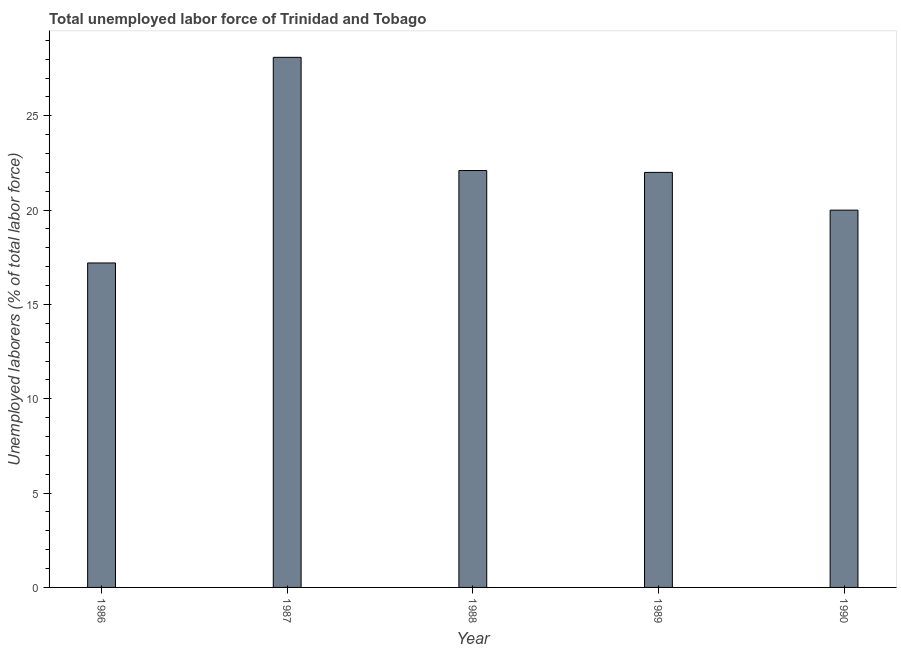Does the graph contain any zero values?
Keep it short and to the point. No. Does the graph contain grids?
Your response must be concise. No. What is the title of the graph?
Offer a very short reply. Total unemployed labor force of Trinidad and Tobago. What is the label or title of the X-axis?
Keep it short and to the point. Year. What is the label or title of the Y-axis?
Offer a very short reply. Unemployed laborers (% of total labor force). What is the total unemployed labour force in 1987?
Provide a succinct answer. 28.1. Across all years, what is the maximum total unemployed labour force?
Your response must be concise. 28.1. Across all years, what is the minimum total unemployed labour force?
Provide a short and direct response. 17.2. In which year was the total unemployed labour force maximum?
Offer a terse response. 1987. In which year was the total unemployed labour force minimum?
Ensure brevity in your answer.  1986. What is the sum of the total unemployed labour force?
Ensure brevity in your answer.  109.4. What is the difference between the total unemployed labour force in 1986 and 1989?
Offer a very short reply. -4.8. What is the average total unemployed labour force per year?
Provide a succinct answer. 21.88. Do a majority of the years between 1990 and 1988 (inclusive) have total unemployed labour force greater than 19 %?
Your answer should be very brief. Yes. What is the ratio of the total unemployed labour force in 1988 to that in 1989?
Make the answer very short. 1. Is the difference between the total unemployed labour force in 1986 and 1988 greater than the difference between any two years?
Your answer should be compact. No. What is the difference between the highest and the second highest total unemployed labour force?
Offer a very short reply. 6. How many bars are there?
Provide a succinct answer. 5. Are all the bars in the graph horizontal?
Offer a very short reply. No. What is the difference between two consecutive major ticks on the Y-axis?
Your answer should be compact. 5. What is the Unemployed laborers (% of total labor force) of 1986?
Provide a short and direct response. 17.2. What is the Unemployed laborers (% of total labor force) of 1987?
Provide a short and direct response. 28.1. What is the Unemployed laborers (% of total labor force) of 1988?
Your response must be concise. 22.1. What is the difference between the Unemployed laborers (% of total labor force) in 1986 and 1988?
Provide a succinct answer. -4.9. What is the difference between the Unemployed laborers (% of total labor force) in 1986 and 1989?
Your answer should be compact. -4.8. What is the difference between the Unemployed laborers (% of total labor force) in 1987 and 1989?
Make the answer very short. 6.1. What is the difference between the Unemployed laborers (% of total labor force) in 1988 and 1990?
Keep it short and to the point. 2.1. What is the ratio of the Unemployed laborers (% of total labor force) in 1986 to that in 1987?
Provide a short and direct response. 0.61. What is the ratio of the Unemployed laborers (% of total labor force) in 1986 to that in 1988?
Give a very brief answer. 0.78. What is the ratio of the Unemployed laborers (% of total labor force) in 1986 to that in 1989?
Provide a succinct answer. 0.78. What is the ratio of the Unemployed laborers (% of total labor force) in 1986 to that in 1990?
Offer a very short reply. 0.86. What is the ratio of the Unemployed laborers (% of total labor force) in 1987 to that in 1988?
Provide a short and direct response. 1.27. What is the ratio of the Unemployed laborers (% of total labor force) in 1987 to that in 1989?
Make the answer very short. 1.28. What is the ratio of the Unemployed laborers (% of total labor force) in 1987 to that in 1990?
Offer a very short reply. 1.41. What is the ratio of the Unemployed laborers (% of total labor force) in 1988 to that in 1990?
Offer a terse response. 1.1. What is the ratio of the Unemployed laborers (% of total labor force) in 1989 to that in 1990?
Your answer should be compact. 1.1. 